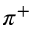Convert formula to latex. <formula><loc_0><loc_0><loc_500><loc_500>\pi ^ { + }</formula> 